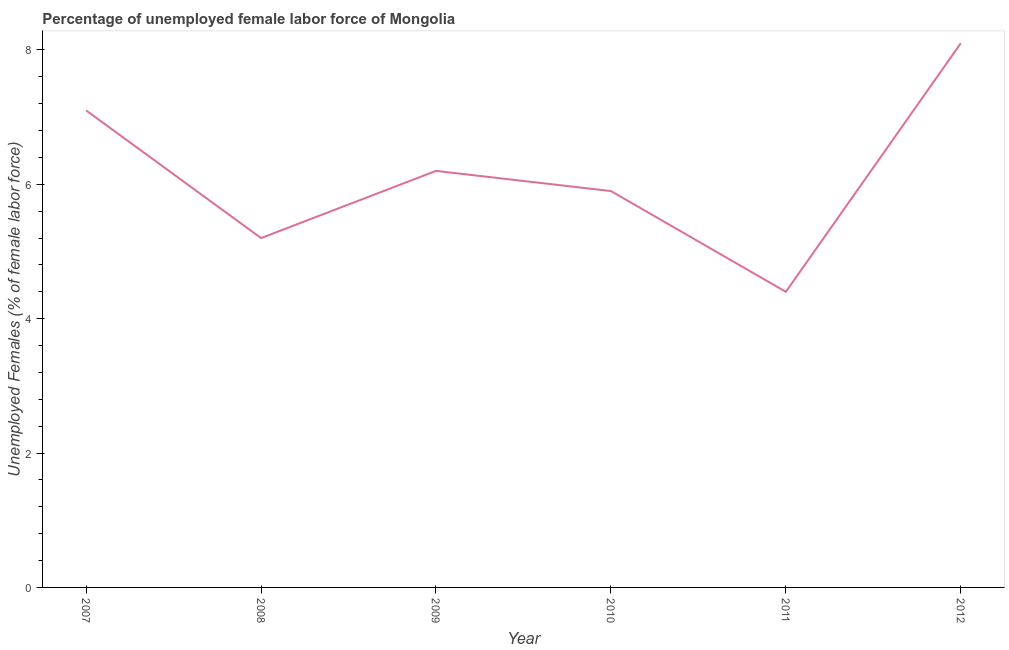What is the total unemployed female labour force in 2011?
Your answer should be very brief. 4.4. Across all years, what is the maximum total unemployed female labour force?
Offer a very short reply. 8.1. Across all years, what is the minimum total unemployed female labour force?
Offer a terse response. 4.4. What is the sum of the total unemployed female labour force?
Keep it short and to the point. 36.9. What is the difference between the total unemployed female labour force in 2009 and 2011?
Make the answer very short. 1.8. What is the average total unemployed female labour force per year?
Your answer should be very brief. 6.15. What is the median total unemployed female labour force?
Provide a short and direct response. 6.05. In how many years, is the total unemployed female labour force greater than 2 %?
Ensure brevity in your answer.  6. Do a majority of the years between 2011 and 2012 (inclusive) have total unemployed female labour force greater than 2 %?
Provide a short and direct response. Yes. What is the ratio of the total unemployed female labour force in 2007 to that in 2011?
Provide a succinct answer. 1.61. Is the total unemployed female labour force in 2010 less than that in 2012?
Provide a short and direct response. Yes. What is the difference between the highest and the second highest total unemployed female labour force?
Provide a succinct answer. 1. What is the difference between the highest and the lowest total unemployed female labour force?
Provide a succinct answer. 3.7. Does the total unemployed female labour force monotonically increase over the years?
Ensure brevity in your answer.  No. How many lines are there?
Make the answer very short. 1. How many years are there in the graph?
Your response must be concise. 6. Are the values on the major ticks of Y-axis written in scientific E-notation?
Give a very brief answer. No. Does the graph contain any zero values?
Provide a succinct answer. No. Does the graph contain grids?
Provide a short and direct response. No. What is the title of the graph?
Your response must be concise. Percentage of unemployed female labor force of Mongolia. What is the label or title of the X-axis?
Your response must be concise. Year. What is the label or title of the Y-axis?
Give a very brief answer. Unemployed Females (% of female labor force). What is the Unemployed Females (% of female labor force) of 2007?
Ensure brevity in your answer.  7.1. What is the Unemployed Females (% of female labor force) in 2008?
Your response must be concise. 5.2. What is the Unemployed Females (% of female labor force) in 2009?
Your answer should be very brief. 6.2. What is the Unemployed Females (% of female labor force) in 2010?
Ensure brevity in your answer.  5.9. What is the Unemployed Females (% of female labor force) of 2011?
Make the answer very short. 4.4. What is the Unemployed Females (% of female labor force) of 2012?
Provide a succinct answer. 8.1. What is the difference between the Unemployed Females (% of female labor force) in 2007 and 2009?
Offer a very short reply. 0.9. What is the difference between the Unemployed Females (% of female labor force) in 2007 and 2010?
Offer a very short reply. 1.2. What is the difference between the Unemployed Females (% of female labor force) in 2007 and 2011?
Make the answer very short. 2.7. What is the difference between the Unemployed Females (% of female labor force) in 2007 and 2012?
Provide a short and direct response. -1. What is the difference between the Unemployed Females (% of female labor force) in 2008 and 2009?
Make the answer very short. -1. What is the difference between the Unemployed Females (% of female labor force) in 2008 and 2010?
Ensure brevity in your answer.  -0.7. What is the difference between the Unemployed Females (% of female labor force) in 2008 and 2012?
Your answer should be compact. -2.9. What is the difference between the Unemployed Females (% of female labor force) in 2009 and 2010?
Your answer should be very brief. 0.3. What is the difference between the Unemployed Females (% of female labor force) in 2009 and 2012?
Ensure brevity in your answer.  -1.9. What is the difference between the Unemployed Females (% of female labor force) in 2010 and 2012?
Keep it short and to the point. -2.2. What is the difference between the Unemployed Females (% of female labor force) in 2011 and 2012?
Offer a terse response. -3.7. What is the ratio of the Unemployed Females (% of female labor force) in 2007 to that in 2008?
Make the answer very short. 1.36. What is the ratio of the Unemployed Females (% of female labor force) in 2007 to that in 2009?
Offer a very short reply. 1.15. What is the ratio of the Unemployed Females (% of female labor force) in 2007 to that in 2010?
Make the answer very short. 1.2. What is the ratio of the Unemployed Females (% of female labor force) in 2007 to that in 2011?
Make the answer very short. 1.61. What is the ratio of the Unemployed Females (% of female labor force) in 2007 to that in 2012?
Offer a terse response. 0.88. What is the ratio of the Unemployed Females (% of female labor force) in 2008 to that in 2009?
Your answer should be very brief. 0.84. What is the ratio of the Unemployed Females (% of female labor force) in 2008 to that in 2010?
Give a very brief answer. 0.88. What is the ratio of the Unemployed Females (% of female labor force) in 2008 to that in 2011?
Provide a short and direct response. 1.18. What is the ratio of the Unemployed Females (% of female labor force) in 2008 to that in 2012?
Provide a succinct answer. 0.64. What is the ratio of the Unemployed Females (% of female labor force) in 2009 to that in 2010?
Make the answer very short. 1.05. What is the ratio of the Unemployed Females (% of female labor force) in 2009 to that in 2011?
Make the answer very short. 1.41. What is the ratio of the Unemployed Females (% of female labor force) in 2009 to that in 2012?
Your answer should be very brief. 0.77. What is the ratio of the Unemployed Females (% of female labor force) in 2010 to that in 2011?
Keep it short and to the point. 1.34. What is the ratio of the Unemployed Females (% of female labor force) in 2010 to that in 2012?
Your answer should be compact. 0.73. What is the ratio of the Unemployed Females (% of female labor force) in 2011 to that in 2012?
Your answer should be very brief. 0.54. 